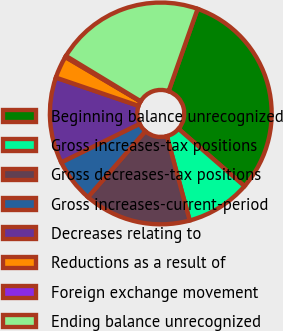Convert chart to OTSL. <chart><loc_0><loc_0><loc_500><loc_500><pie_chart><fcel>Beginning balance unrecognized<fcel>Gross increases-tax positions<fcel>Gross decreases-tax positions<fcel>Gross increases-current-period<fcel>Decreases relating to<fcel>Reductions as a result of<fcel>Foreign exchange movement<fcel>Ending balance unrecognized<nl><fcel>31.0%<fcel>9.42%<fcel>15.59%<fcel>6.34%<fcel>12.51%<fcel>3.26%<fcel>0.18%<fcel>21.71%<nl></chart> 